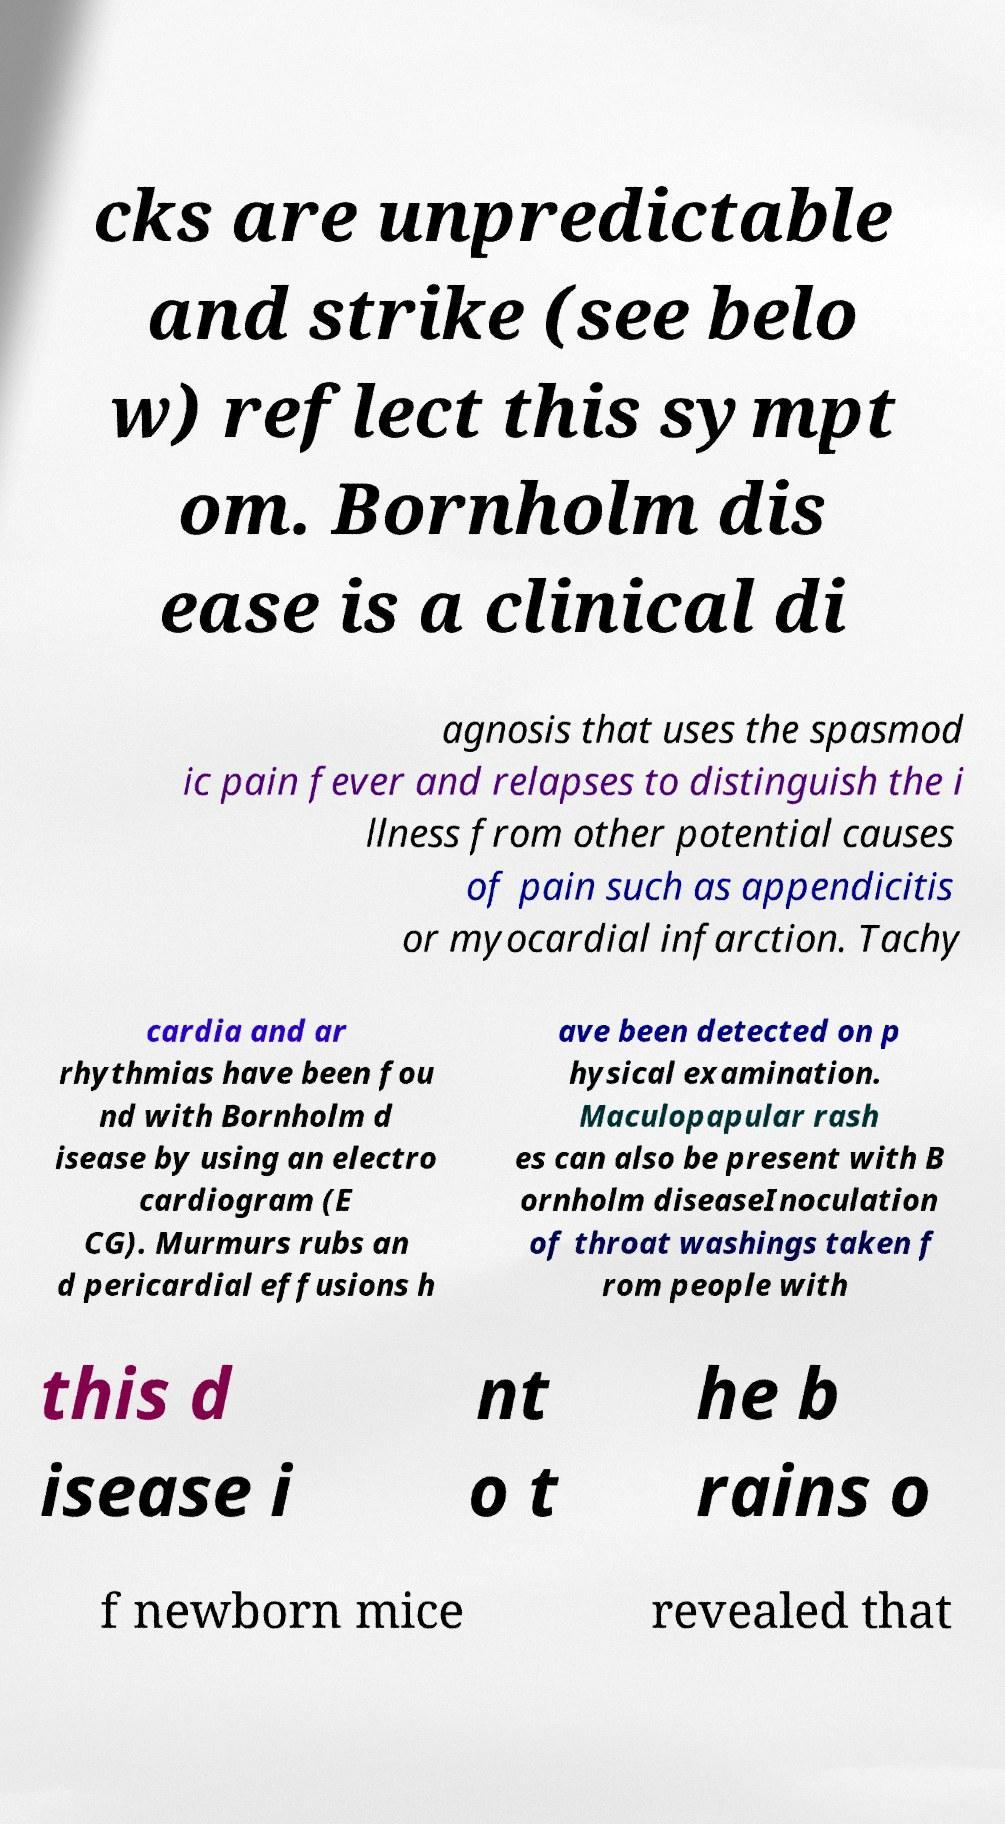Could you extract and type out the text from this image? cks are unpredictable and strike (see belo w) reflect this sympt om. Bornholm dis ease is a clinical di agnosis that uses the spasmod ic pain fever and relapses to distinguish the i llness from other potential causes of pain such as appendicitis or myocardial infarction. Tachy cardia and ar rhythmias have been fou nd with Bornholm d isease by using an electro cardiogram (E CG). Murmurs rubs an d pericardial effusions h ave been detected on p hysical examination. Maculopapular rash es can also be present with B ornholm diseaseInoculation of throat washings taken f rom people with this d isease i nt o t he b rains o f newborn mice revealed that 